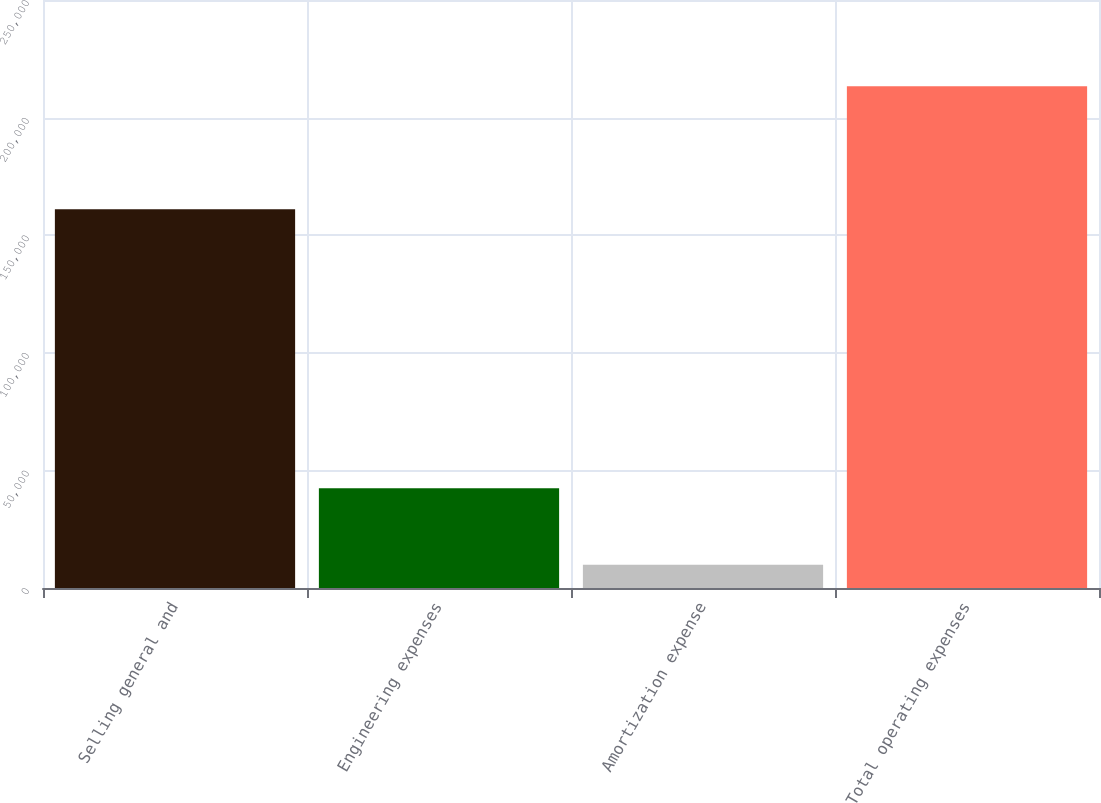<chart> <loc_0><loc_0><loc_500><loc_500><bar_chart><fcel>Selling general and<fcel>Engineering expenses<fcel>Amortization expense<fcel>Total operating expenses<nl><fcel>160998<fcel>42447<fcel>9849<fcel>213294<nl></chart> 